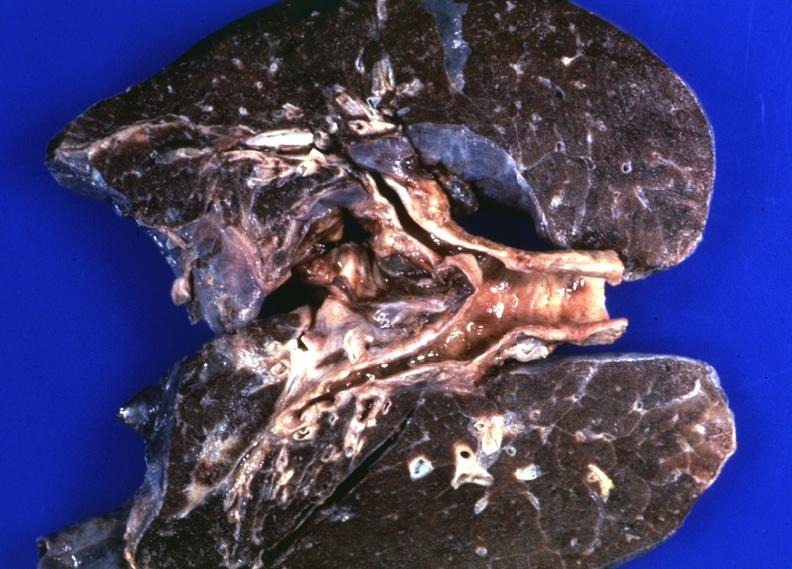does acute inflammation show lungs, hemochromatosis?
Answer the question using a single word or phrase. No 